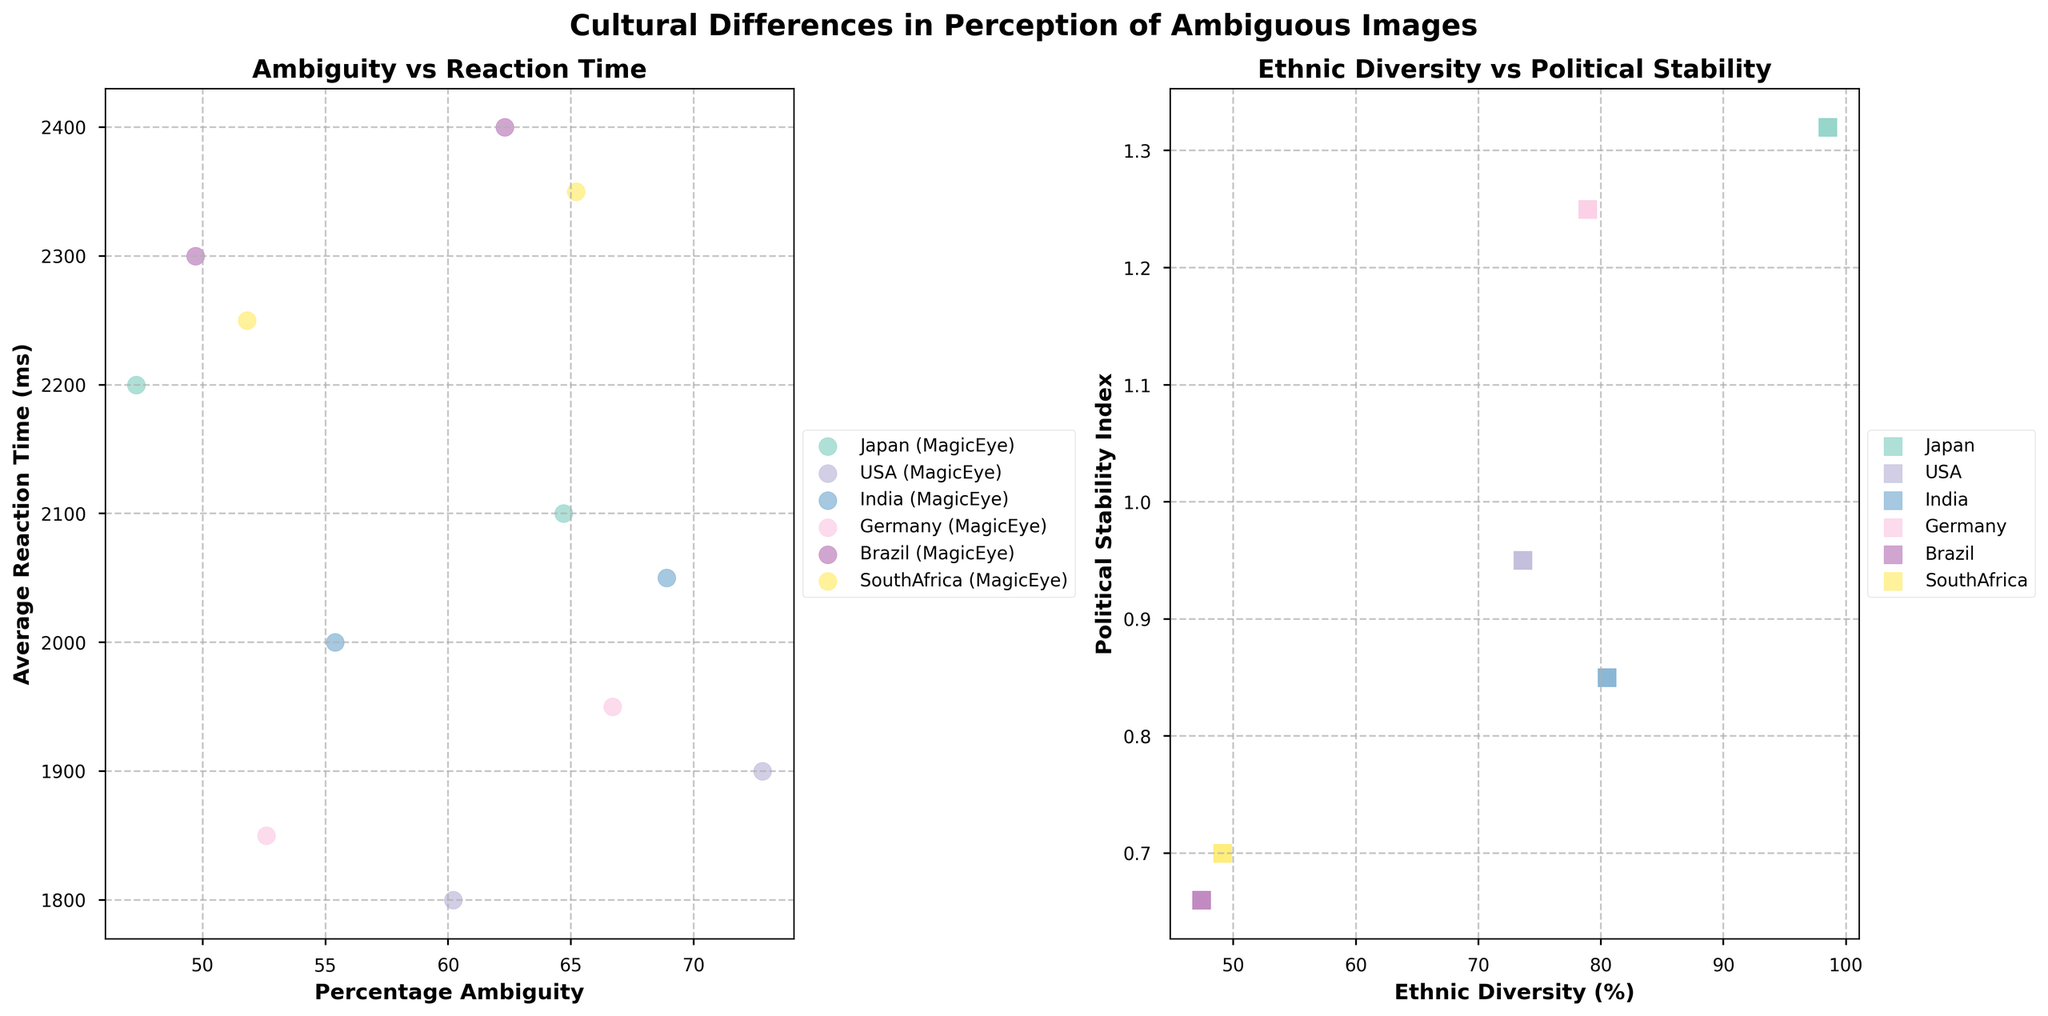What does the title of the subplot indicate about the study? The title "Cultural Differences in Perception of Ambiguous Images" suggests that the study explores how different cultures perceive images that are not easily defined or classified, comparing the ambiguity percentages and reaction times across various countries.
Answer: It explores cultural differences in perceiving ambiguous images Which country shows the highest percentage of ambiguity for MagicEye images? By examining the scatter plot under 'MagicEye' markers, it is clear the USA has the highest percentage of ambiguity for MagicEye images, which can also be confirmed from the data (60.2%).
Answer: USA How does reaction time correlate with percentage ambiguity across different image types? By examining both image types in the first subplot, we see that countries with higher percentage ambiguity tend to have shorter reaction times, indicating a possible inverse relationship. For example, the USA has high ambiguity and shorter reaction times for both image types. More detailed data analysis would be needed to confirm all patterns.
Answer: Possible inverse relationship Which country exhibits the highest political stability, and what is its corresponding ethnic diversity percentage? In the scatter plot for 'Ethnic Diversity vs Political Stability,' the country with the highest political stability index is Japan (1.32). Referring to the data, Japan's corresponding ethnic diversity percentage is 98.5%.
Answer: Japan, 98.5% How do the perceptions of ambiguous images differ between Japan and South Africa based on the given figure? For both MagicEye and Rorschach images, Japan shows higher percentages of ambiguity and lower reaction times compared to South Africa, indicating that Japanese participants perceive the images as more ambiguous but respond faster.
Answer: Japan shows higher ambiguity and faster reaction times Which image type results in a wider range of reaction times across all countries? By comparing the spread of reaction times on the x-axis in the 'MagicEye' and 'Rorschach' subplots, Rorschach images show a wider range of reaction times (1900ms to 2400ms) than MagicEye images (1800ms to 2300ms).
Answer: Rorschach Compare the ethnic diversity and political stability between India and Brazil. Which country is more diverse, and which has higher political stability? From the subplot on 'Ethnic Diversity vs Political Stability,' India has a higher ethnic diversity percentage (80.5%) compared to Brazil (47.4%). However, Brazil has a lower political stability index (0.66) compared to India (0.85).
Answer: India is more diverse; India has higher political stability What is the relationship between ethnic diversity and political stability for countries with less than 50% diversity? Observing the scatter plot for countries with less than 50% diversity (specifically Brazil and South Africa), both these countries have relatively low political stability indices, suggesting a potential relationship where less ethnic diversity might correlate with lower political stability.
Answer: Possible correlation with lower political stability 